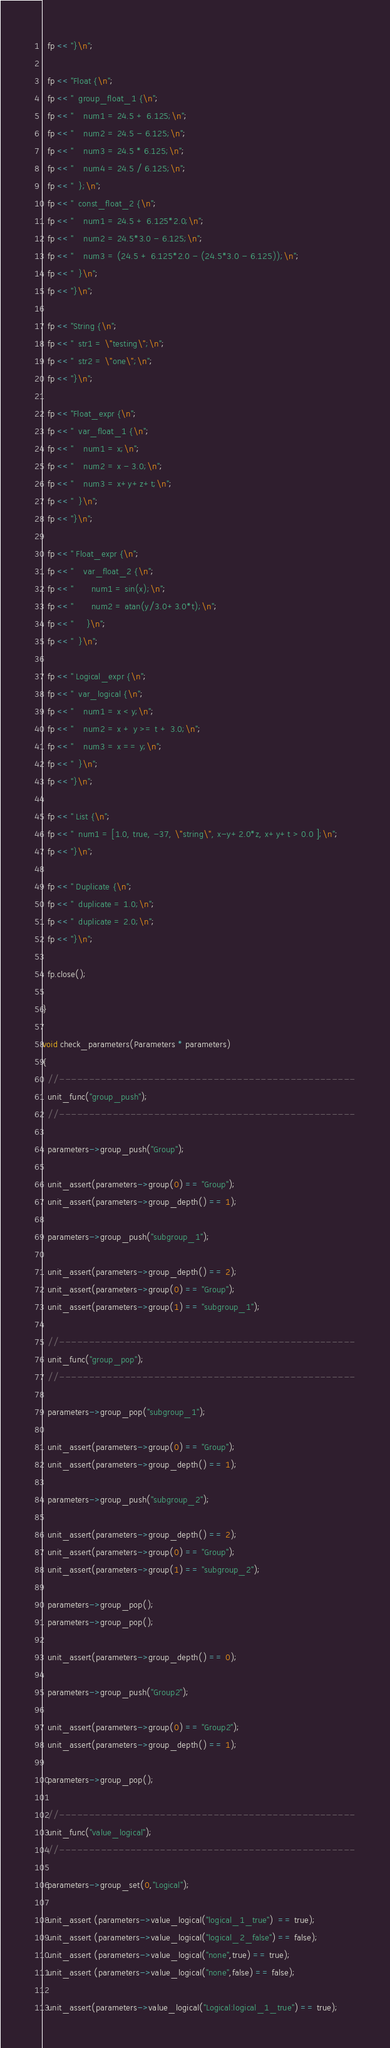Convert code to text. <code><loc_0><loc_0><loc_500><loc_500><_C++_>  fp << "}\n";

  fp << "Float {\n";
  fp << "  group_float_1 {\n";
  fp << "    num1 = 24.5 + 6.125;\n";
  fp << "    num2 = 24.5 - 6.125;\n";
  fp << "    num3 = 24.5 * 6.125;\n";
  fp << "    num4 = 24.5 / 6.125;\n";
  fp << "  };\n";
  fp << "  const_float_2 {\n";
  fp << "    num1 = 24.5 + 6.125*2.0;\n";
  fp << "    num2 = 24.5*3.0 - 6.125;\n";
  fp << "    num3 = (24.5 + 6.125*2.0 - (24.5*3.0 - 6.125));\n";
  fp << "  }\n";
  fp << "}\n";

  fp << "String {\n";
  fp << "  str1 = \"testing\";\n";
  fp << "  str2 = \"one\";\n";
  fp << "}\n";

  fp << "Float_expr {\n";
  fp << "  var_float_1 {\n";
  fp << "    num1 = x;\n";
  fp << "    num2 = x - 3.0;\n";
  fp << "    num3 = x+y+z+t;\n";
  fp << "  }\n";
  fp << "}\n";

  fp << " Float_expr {\n";
  fp << "    var_float_2 {\n";
  fp << "       num1 = sin(x);\n";
  fp << "       num2 = atan(y/3.0+3.0*t);\n";
  fp << "     }\n";
  fp << "  }\n";

  fp << " Logical_expr {\n";
  fp << "  var_logical {\n";
  fp << "    num1 = x < y;\n";
  fp << "    num2 = x + y >= t + 3.0;\n";
  fp << "    num3 = x == y;\n";
  fp << "  }\n";
  fp << "}\n";

  fp << " List {\n";
  fp << "  num1 = [1.0, true, -37, \"string\", x-y+2.0*z, x+y+t > 0.0 ];\n";
  fp << "}\n";

  fp << " Duplicate {\n";
  fp << "  duplicate = 1.0;\n";
  fp << "  duplicate = 2.0;\n";
  fp << "}\n";

  fp.close();

}

void check_parameters(Parameters * parameters)
{
  //--------------------------------------------------
  unit_func("group_push");
  //--------------------------------------------------

  parameters->group_push("Group");

  unit_assert(parameters->group(0) == "Group");
  unit_assert(parameters->group_depth() == 1);

  parameters->group_push("subgroup_1");

  unit_assert(parameters->group_depth() == 2);
  unit_assert(parameters->group(0) == "Group");
  unit_assert(parameters->group(1) == "subgroup_1");

  //--------------------------------------------------
  unit_func("group_pop");
  //--------------------------------------------------

  parameters->group_pop("subgroup_1");

  unit_assert(parameters->group(0) == "Group");
  unit_assert(parameters->group_depth() == 1);

  parameters->group_push("subgroup_2");

  unit_assert(parameters->group_depth() == 2);
  unit_assert(parameters->group(0) == "Group");
  unit_assert(parameters->group(1) == "subgroup_2");

  parameters->group_pop();
  parameters->group_pop();

  unit_assert(parameters->group_depth() == 0);

  parameters->group_push("Group2");

  unit_assert(parameters->group(0) == "Group2");
  unit_assert(parameters->group_depth() == 1);

  parameters->group_pop();

  //--------------------------------------------------
  unit_func("value_logical");
  //--------------------------------------------------

  parameters->group_set(0,"Logical");
  
  unit_assert (parameters->value_logical("logical_1_true")  == true);
  unit_assert (parameters->value_logical("logical_2_false") == false);
  unit_assert (parameters->value_logical("none",true) == true);
  unit_assert (parameters->value_logical("none",false) == false);

  unit_assert(parameters->value_logical("Logical:logical_1_true") == true);</code> 